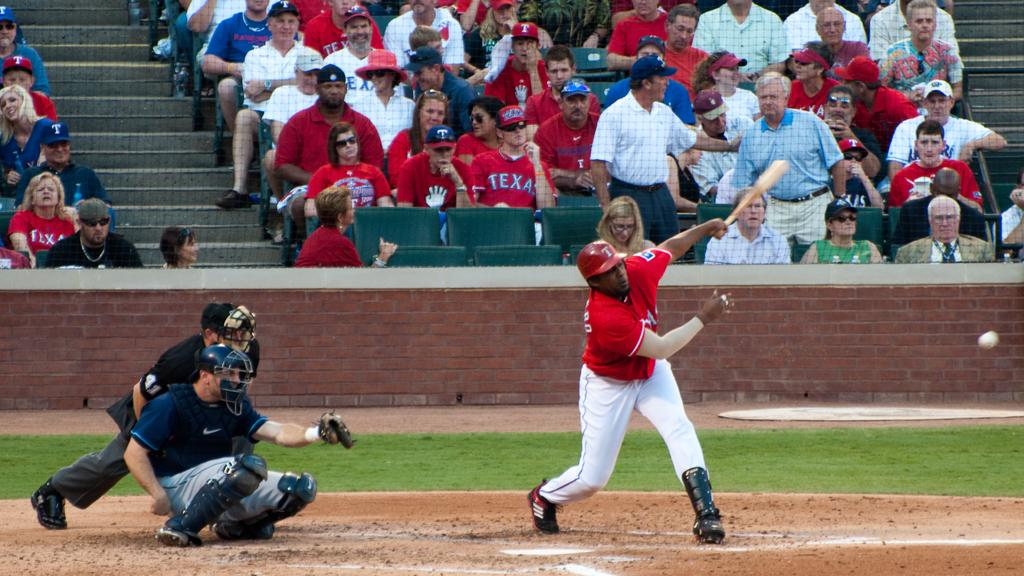<image>
Offer a succinct explanation of the picture presented. Some spectators wear Texas uniforms while watching a batter take a swing. 